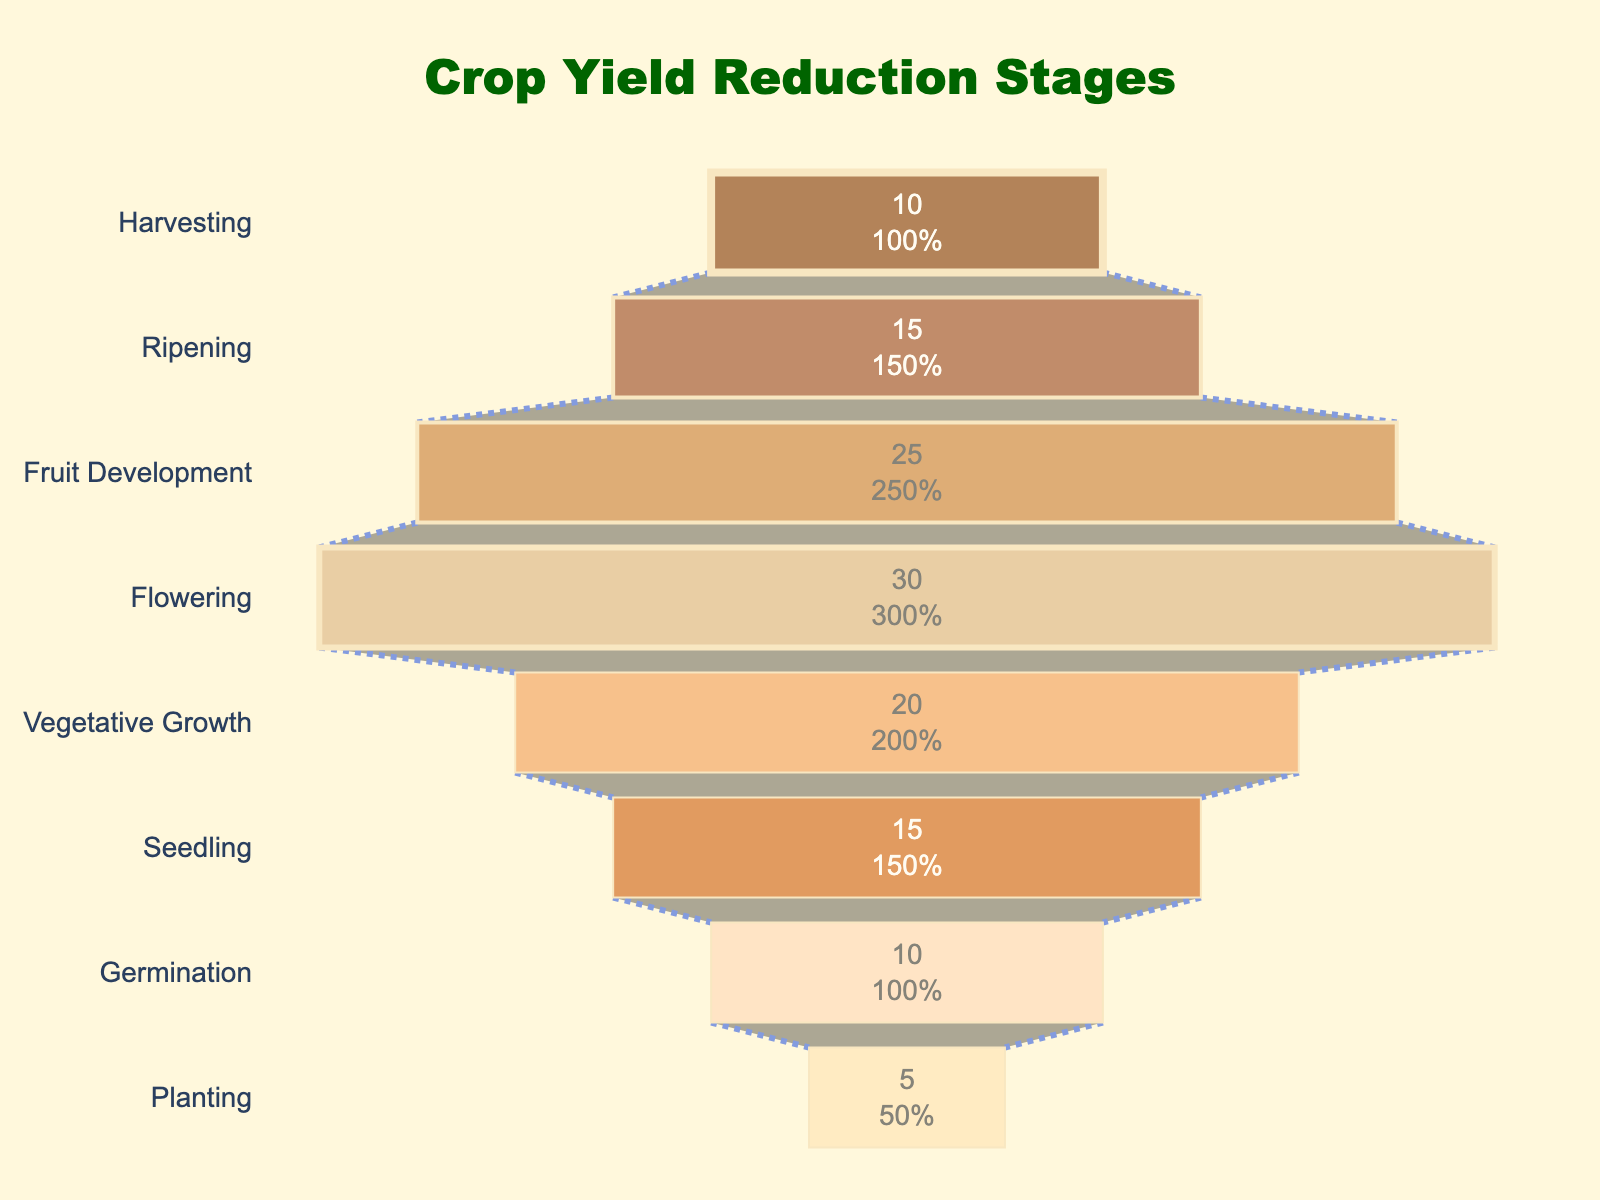Which stage has the highest percentage loss? To find the stage with the highest percentage loss, scan through each stage in the funnel chart and identify the one with the maximum percentage.
Answer: Flowering What's the combined percentage loss from Planting to Seedling? Add the percentage loss values from the Planting, Germination, and Seedling stages. These are 5%, 10%, and 15%, respectively. The total is 5 + 10 + 15.
Answer: 30% Which stages have a percentage loss of 15%? Look at each stage's percentage loss value and note which ones are 15%. Both the Seedling and Ripening stages have a 15% loss.
Answer: Seedling, Ripening Compare the percentage loss between Fruit Development and Harvesting stages. Which one is higher? Review the percentage loss values for both stages: Fruit Development has a 25% loss, while Harvesting has a 10% loss. Therefore, Fruit Development has a higher percentage loss.
Answer: Fruit Development What is the percentage loss at the Vegetative Growth stage relative to the entire reduction funnel? The Vegetative Growth stage loss is 20%. The funnel chart visually represents all stages, indicating that this stage's percentage loss is part of the total crop yield reduction.
Answer: 20% How does the percentage loss change from the Flowering stage to the Fruit Development stage? To identify the change, subtract the Flowering stage loss (30%) from the Fruit Development stage loss (25%). The percentage loss decreases by 5%.
Answer: -5% What is the average percentage loss across all stages? Sum the percentage losses of all stages and divide by the number of stages: (5 + 10 + 15 + 20 + 30 + 25 + 15 + 10) / 8 = 130 / 8.
Answer: 16.25% Which stages exhibit a loss greater than 20%? Identify stages where the percentage loss is greater than 20%. These are the Flowering (30%) and Fruit Development (25%) stages.
Answer: Flowering, Fruit Development 